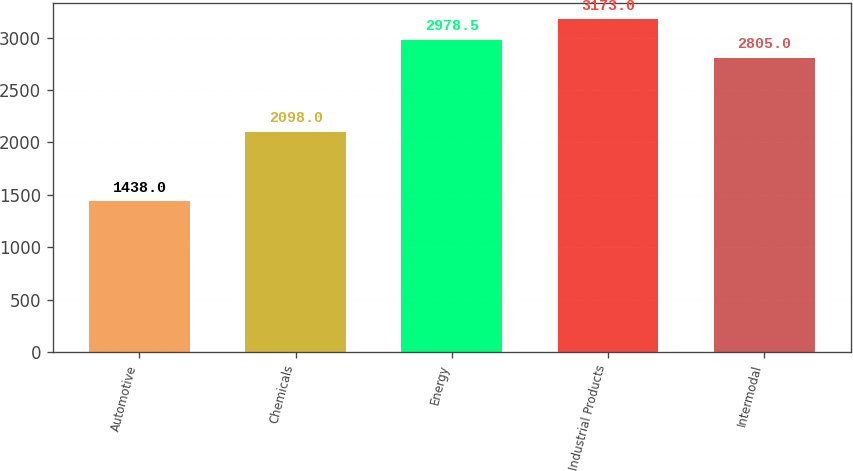Convert chart to OTSL. <chart><loc_0><loc_0><loc_500><loc_500><bar_chart><fcel>Automotive<fcel>Chemicals<fcel>Energy<fcel>Industrial Products<fcel>Intermodal<nl><fcel>1438<fcel>2098<fcel>2978.5<fcel>3173<fcel>2805<nl></chart> 